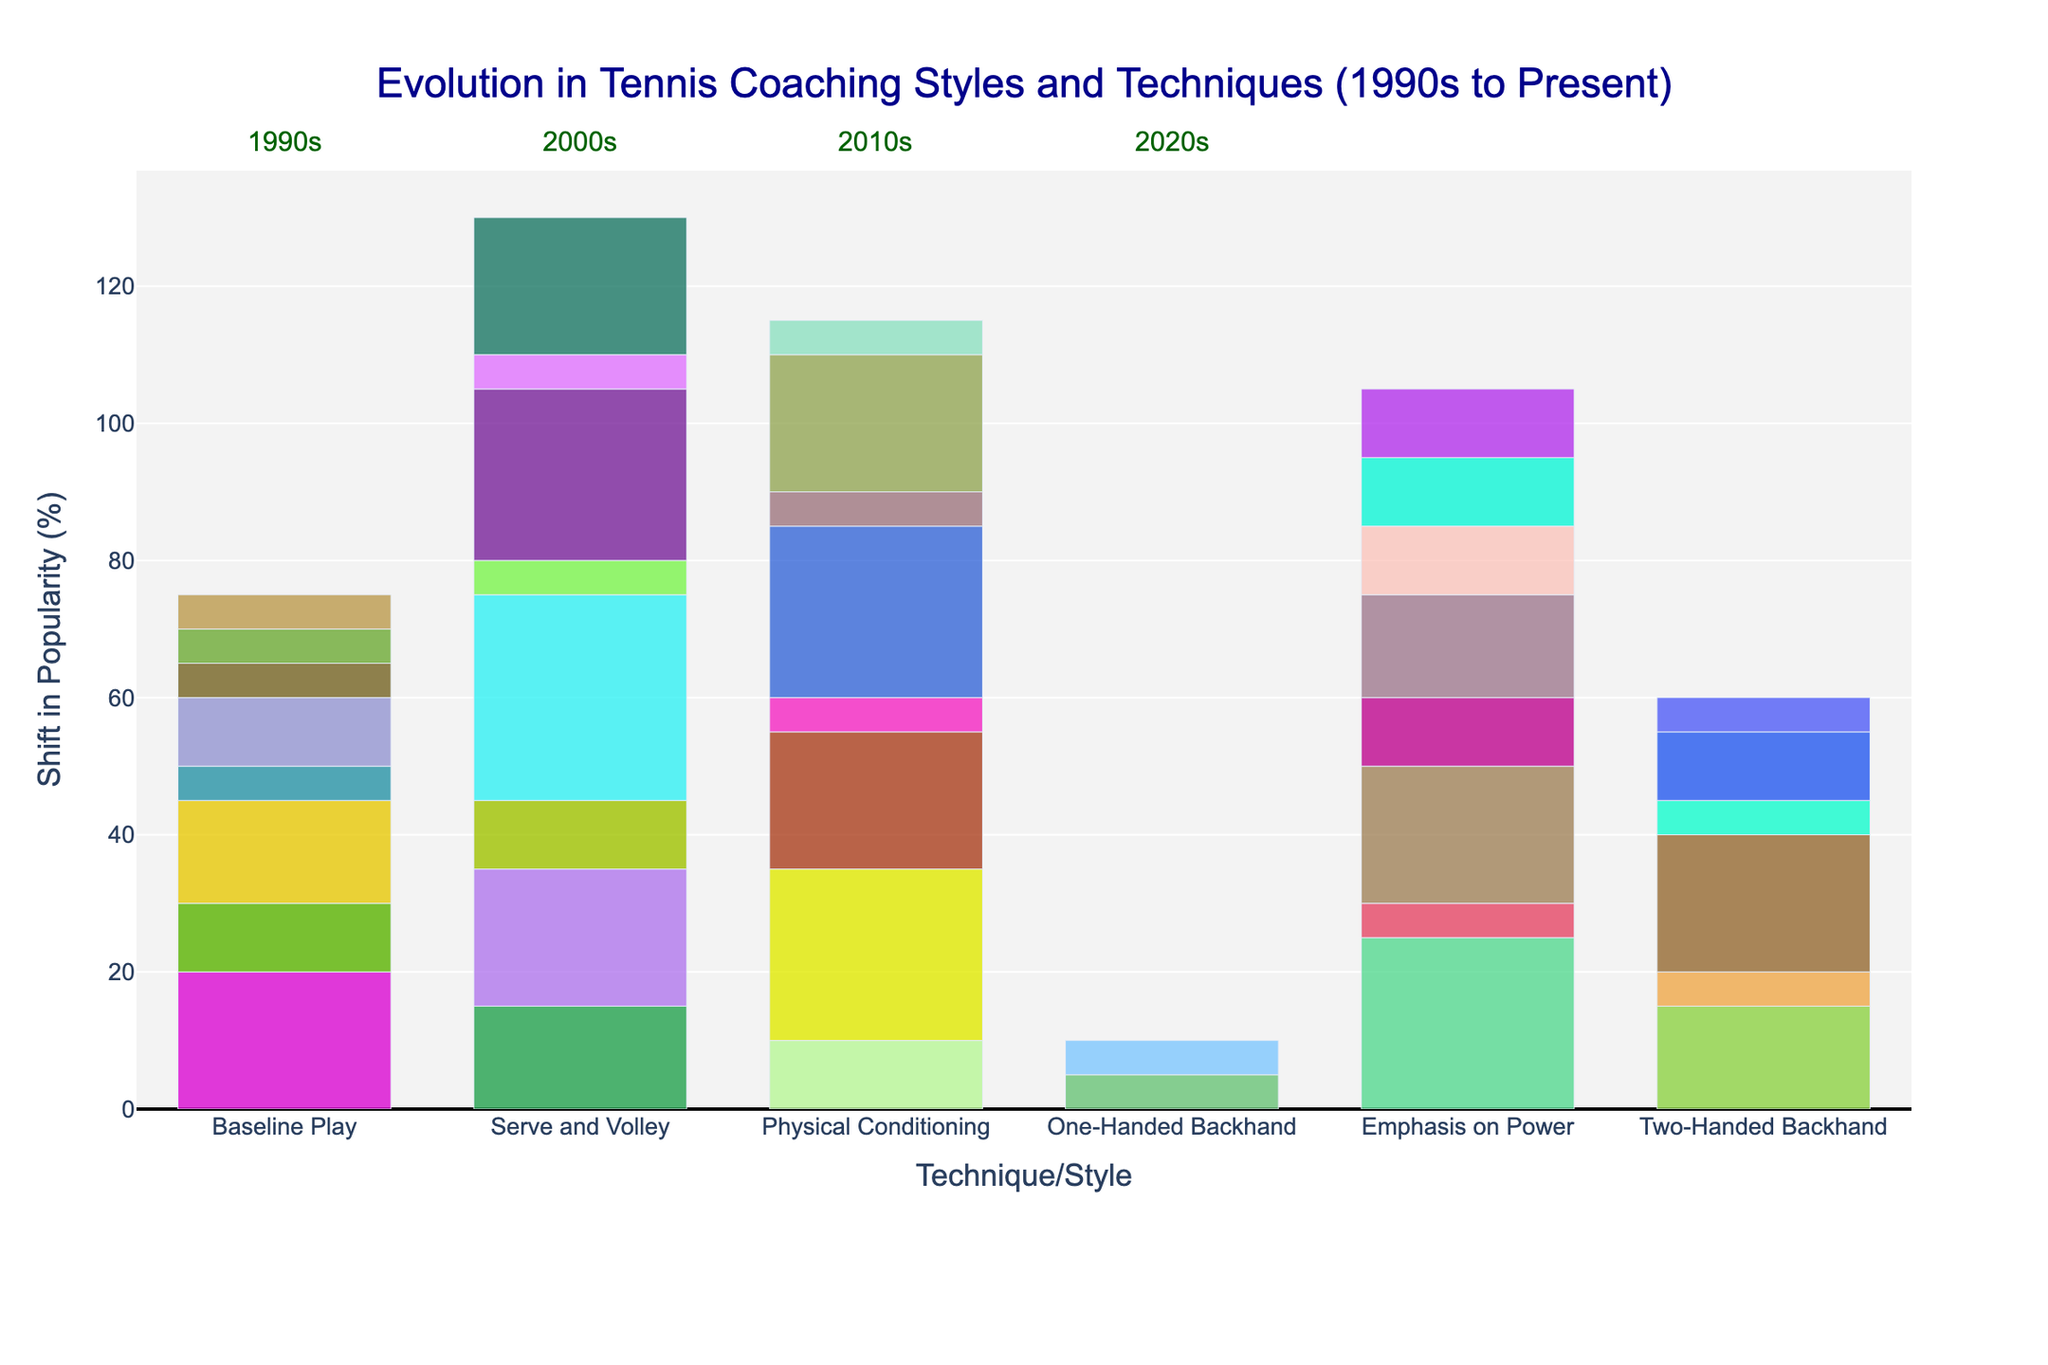What technique experienced the most negative shift across all eras? To determine the technique with the most negative shift, we must compare the negative shift values of all techniques across different eras. Serve and Volley has the largest negative shift of -30 in the 2000s.
Answer: Serve and Volley How does the popularity of Baseline Play in the 2020s compare to its popularity in the 1990s? Baseline Play was 60% popular in the 1990s and increased to 80% in the 2020s. The difference in popularity is 80% - 60% = 20%.
Answer: 20% more popular Which era saw the highest increase in Physical Conditioning? By examining the positive shift values, Physical Conditioning in the 2010s had the highest increase with a positive shift of 25.
Answer: 2010s Compare the positive shifts in Two-Handed Backhand between the 2000s and 2010s. Which era had a greater increase? The positive shift for Two-Handed Backhand was 15 in the 2000s and 20 in the 2010s. Thus, the 2010s saw a greater increase by 5 units.
Answer: 2010s What is the average positive shift for Emphasis on Power over all eras? Calculate the average by summing the positive shifts of Emphasis on Power over all eras and dividing by the number of eras: (25 + 20 + 15 + 10) / 4 = 17.5.
Answer: 17.5 Which technique saw a consistent positive shift across all eras? Emphasis on Power had positive shifts in every era: 25, 20, 15, and 10.
Answer: Emphasis on Power How do the positive shifts of Serve and Volley in the 1990s and 2000s compare? Serve and Volley experienced positive shifts of 15 in the 1990s and 10 in the 2000s. Thus, it had a 5-unit greater shift in the 1990s.
Answer: 1990s What was the total negative shift for Physical Conditioning in the 1990s and 2000s? Sum the negative shifts: -25 (1990s) + (-5) (2000s) = -30.
Answer: -30 Which era had the smallest positive shift for Baseline Play? Baseline Play had positive shifts of 20 (1990s), 15 (2000s), 10 (2010s), and 5 (2020s). The smallest positive shift was 5 in the 2020s.
Answer: 2020s What is the net shift (positive minus negative shift) for One-Handed Backhand in the 1990s? Compute the net shift by subtracting negative shift from positive shift: 5 - 5 = 0.
Answer: 0 